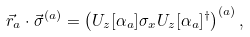<formula> <loc_0><loc_0><loc_500><loc_500>\vec { r } _ { a } \cdot \vec { \sigma } ^ { ( a ) } = \left ( U _ { z } [ \alpha _ { a } ] \sigma _ { x } U _ { z } [ \alpha _ { a } ] ^ { \dagger } \right ) ^ { ( a ) } ,</formula> 